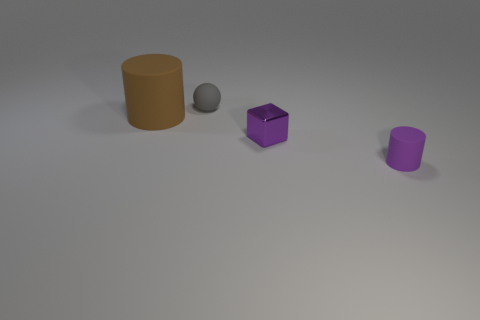Subtract all balls. How many objects are left? 3 Subtract 1 blocks. How many blocks are left? 0 Add 3 cyan rubber blocks. How many objects exist? 7 Subtract 0 red cylinders. How many objects are left? 4 Subtract all blue blocks. Subtract all green cylinders. How many blocks are left? 1 Subtract all green cylinders. How many yellow balls are left? 0 Subtract all gray matte balls. Subtract all gray rubber spheres. How many objects are left? 2 Add 3 purple metal objects. How many purple metal objects are left? 4 Add 4 gray balls. How many gray balls exist? 5 Subtract all brown cylinders. How many cylinders are left? 1 